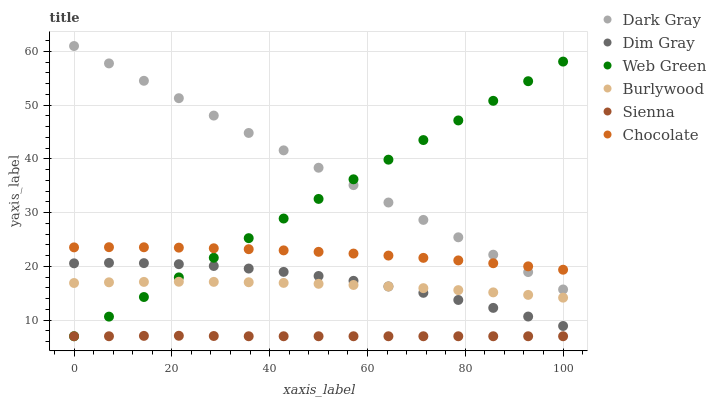Does Sienna have the minimum area under the curve?
Answer yes or no. Yes. Does Dark Gray have the maximum area under the curve?
Answer yes or no. Yes. Does Dim Gray have the minimum area under the curve?
Answer yes or no. No. Does Dim Gray have the maximum area under the curve?
Answer yes or no. No. Is Web Green the smoothest?
Answer yes or no. Yes. Is Dim Gray the roughest?
Answer yes or no. Yes. Is Burlywood the smoothest?
Answer yes or no. No. Is Burlywood the roughest?
Answer yes or no. No. Does Sienna have the lowest value?
Answer yes or no. Yes. Does Dim Gray have the lowest value?
Answer yes or no. No. Does Dark Gray have the highest value?
Answer yes or no. Yes. Does Dim Gray have the highest value?
Answer yes or no. No. Is Sienna less than Dim Gray?
Answer yes or no. Yes. Is Dark Gray greater than Burlywood?
Answer yes or no. Yes. Does Chocolate intersect Dark Gray?
Answer yes or no. Yes. Is Chocolate less than Dark Gray?
Answer yes or no. No. Is Chocolate greater than Dark Gray?
Answer yes or no. No. Does Sienna intersect Dim Gray?
Answer yes or no. No. 